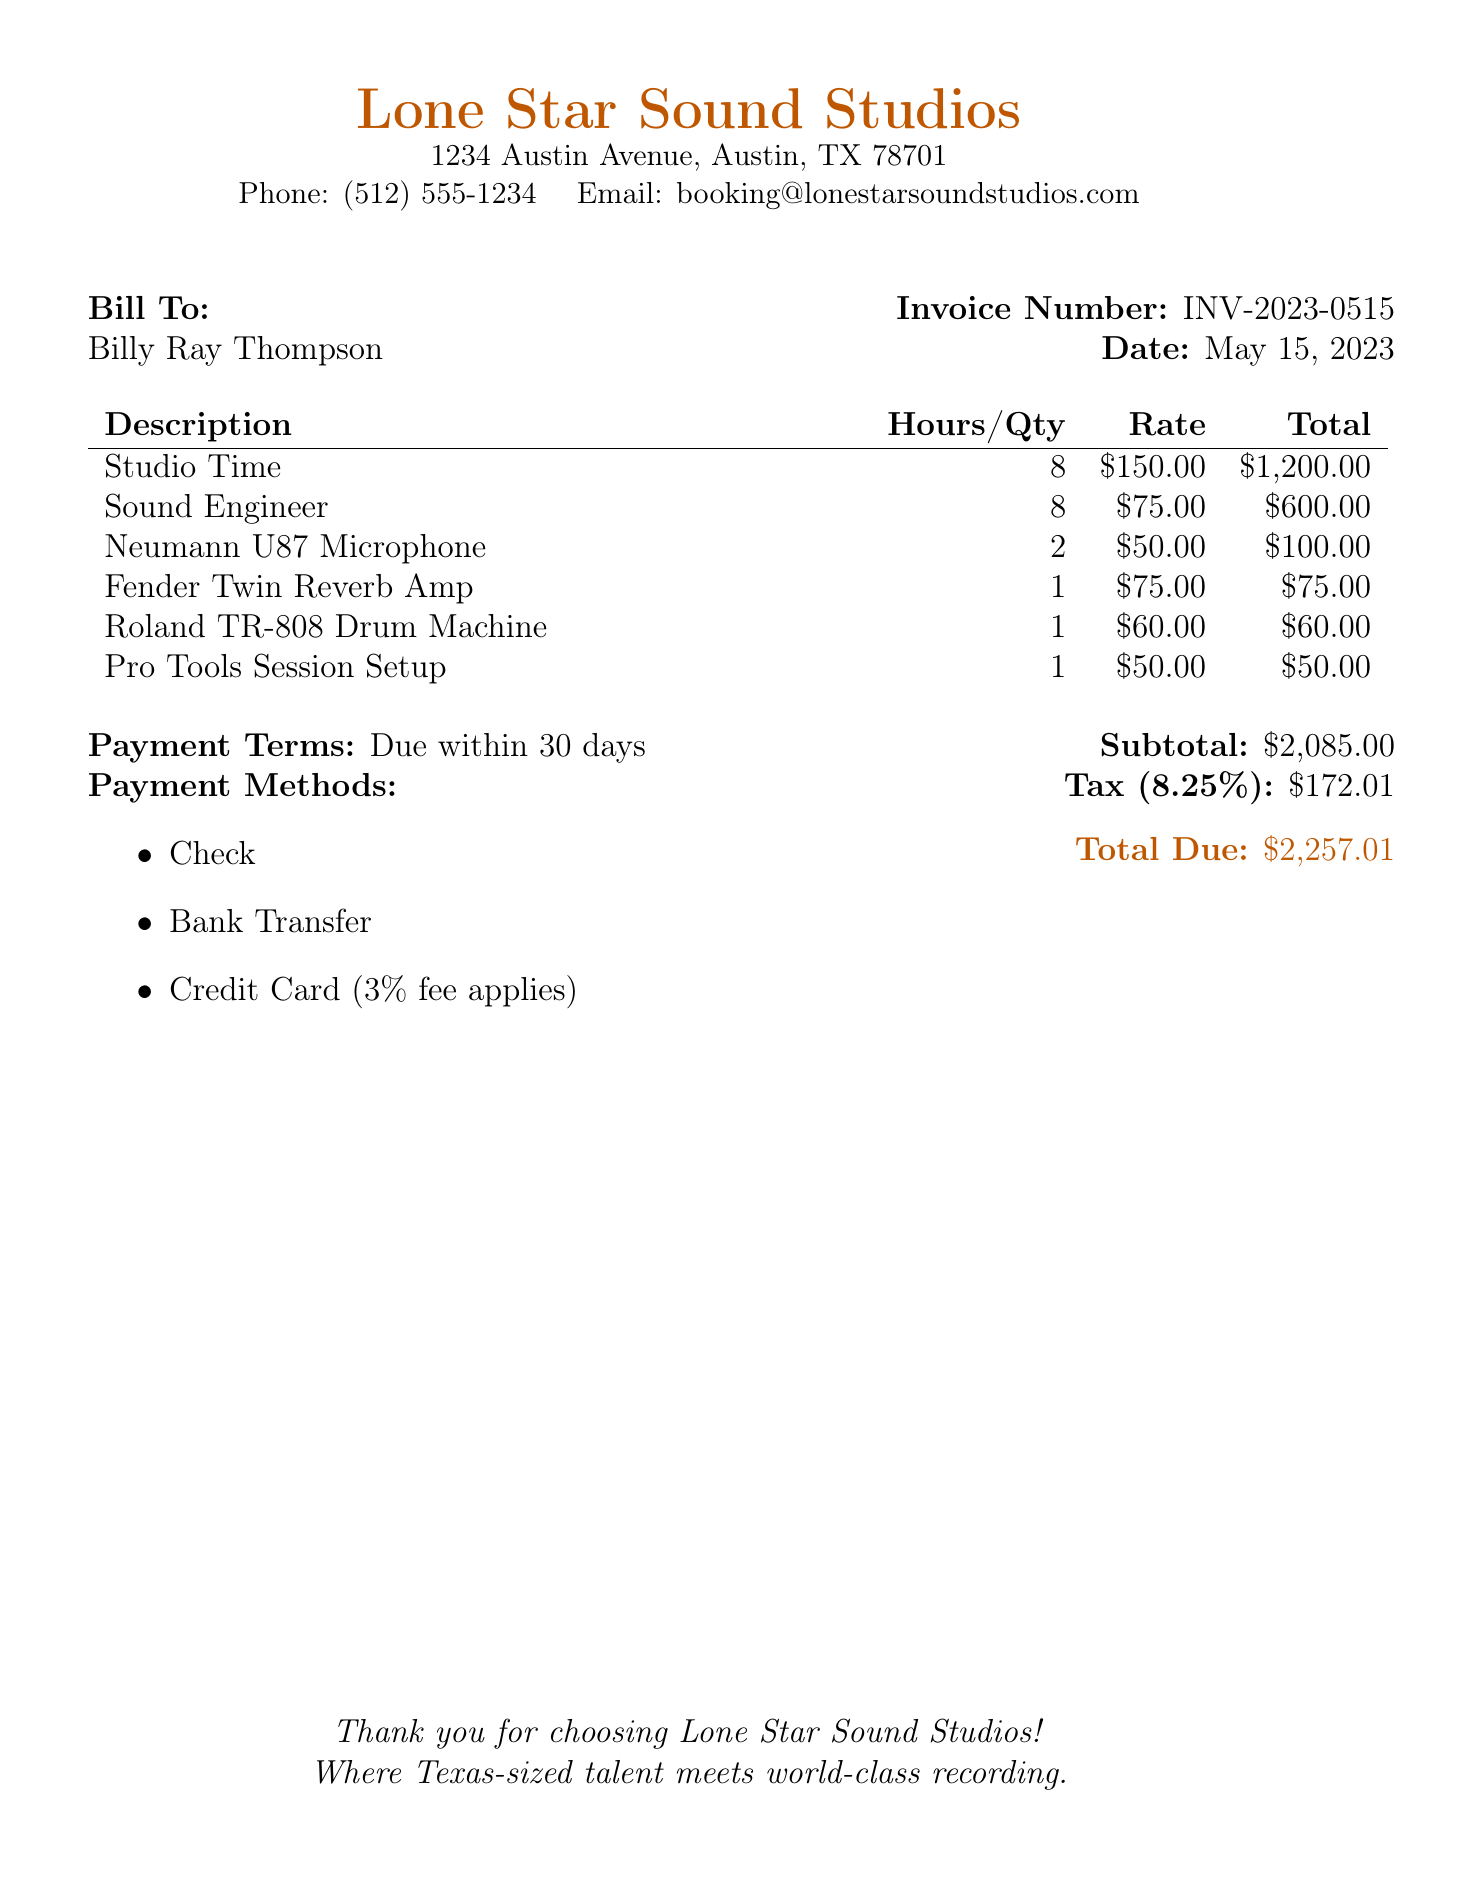What is the invoice number? The invoice number is specified clearly in the document, listed after "Invoice Number."
Answer: INV-2023-0515 What is the total due amount? The total due amount is provided at the bottom of the bill under "Total Due."
Answer: $2,257.01 How many hours of studio time were billed? The hours for studio time are indicated in the itemized costs for "Studio Time."
Answer: 8 What is the tax rate applied to the bill? The tax rate is mentioned in the subtotal section of the document.
Answer: 8.25% Who is the bill addressed to? The name of the person being billed is stated at the top as "Bill To."
Answer: Billy Ray Thompson What payment method incurs an additional fee? The document specifies that if payment is made by a certain method, a fee applies.
Answer: Credit Card What is the cost for the Neumann U87 Microphone? The itemized cost for the Neumann U87 Microphone is listed in the table.
Answer: $100.00 What is the duration for the payment terms? The payment terms specify a certain duration for when payment is due.
Answer: 30 days How much is charged for the sound engineer? The rate for the sound engineer is provided in the costs listed.
Answer: $600.00 